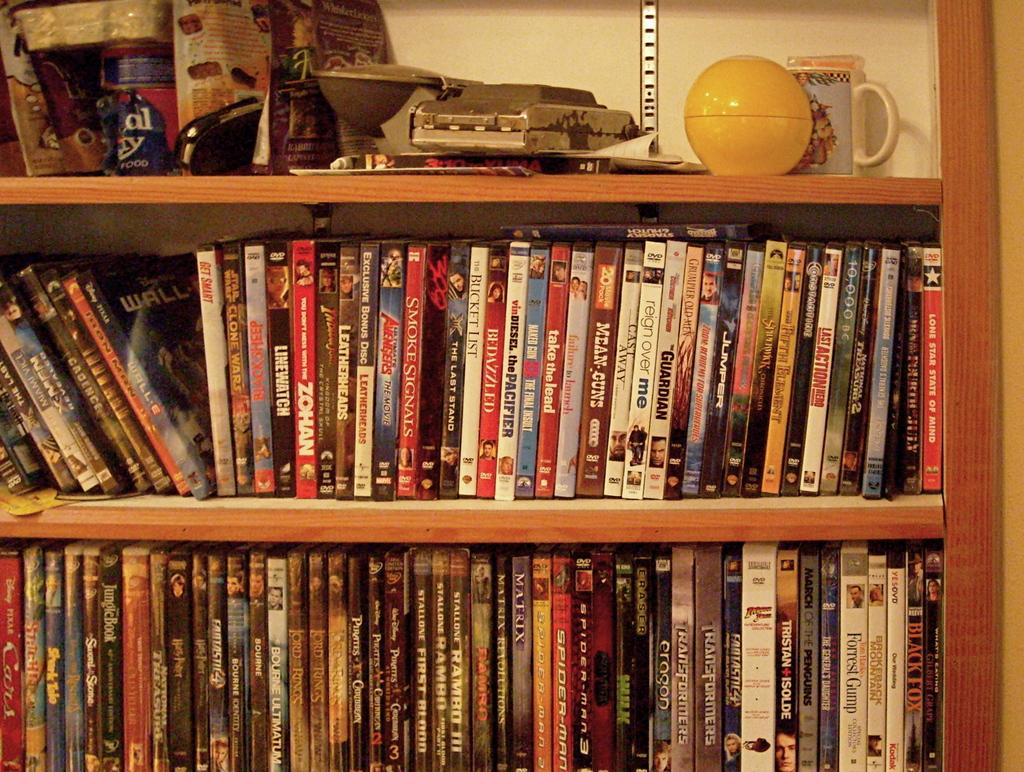<image>
Write a terse but informative summary of the picture. Shelf with many films including one that says "Take the lead". 